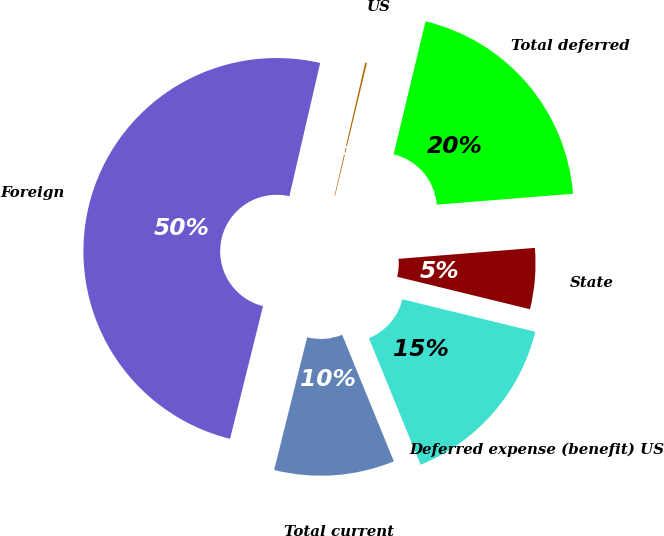Convert chart to OTSL. <chart><loc_0><loc_0><loc_500><loc_500><pie_chart><fcel>US<fcel>Foreign<fcel>Total current<fcel>Deferred expense (benefit) US<fcel>State<fcel>Total deferred<nl><fcel>0.14%<fcel>49.73%<fcel>10.05%<fcel>15.01%<fcel>5.09%<fcel>19.97%<nl></chart> 